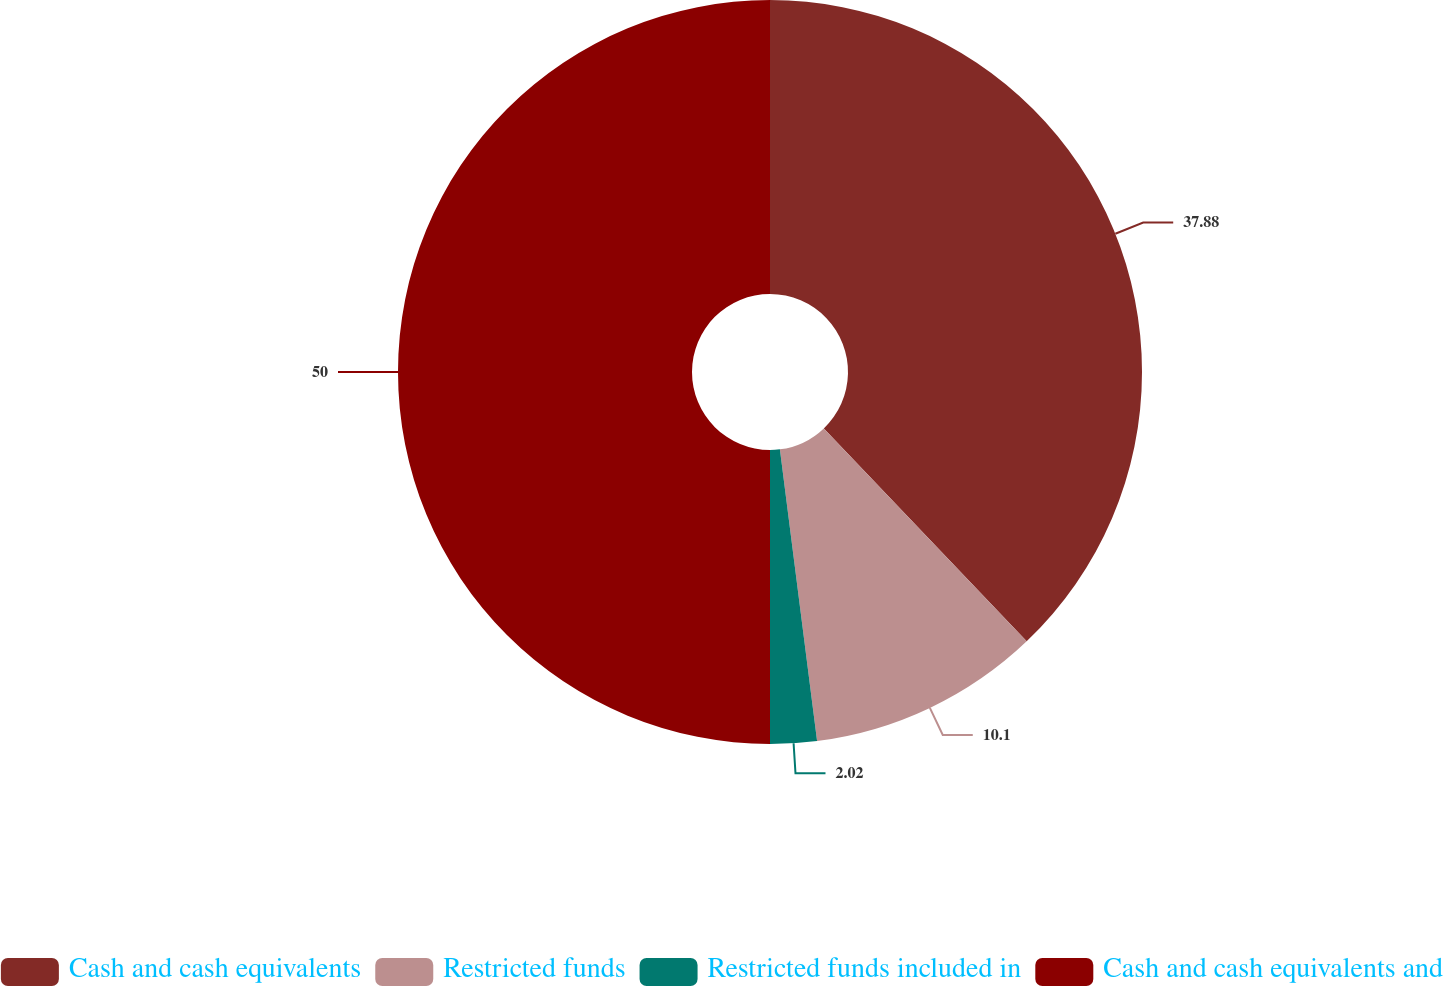<chart> <loc_0><loc_0><loc_500><loc_500><pie_chart><fcel>Cash and cash equivalents<fcel>Restricted funds<fcel>Restricted funds included in<fcel>Cash and cash equivalents and<nl><fcel>37.88%<fcel>10.1%<fcel>2.02%<fcel>50.0%<nl></chart> 